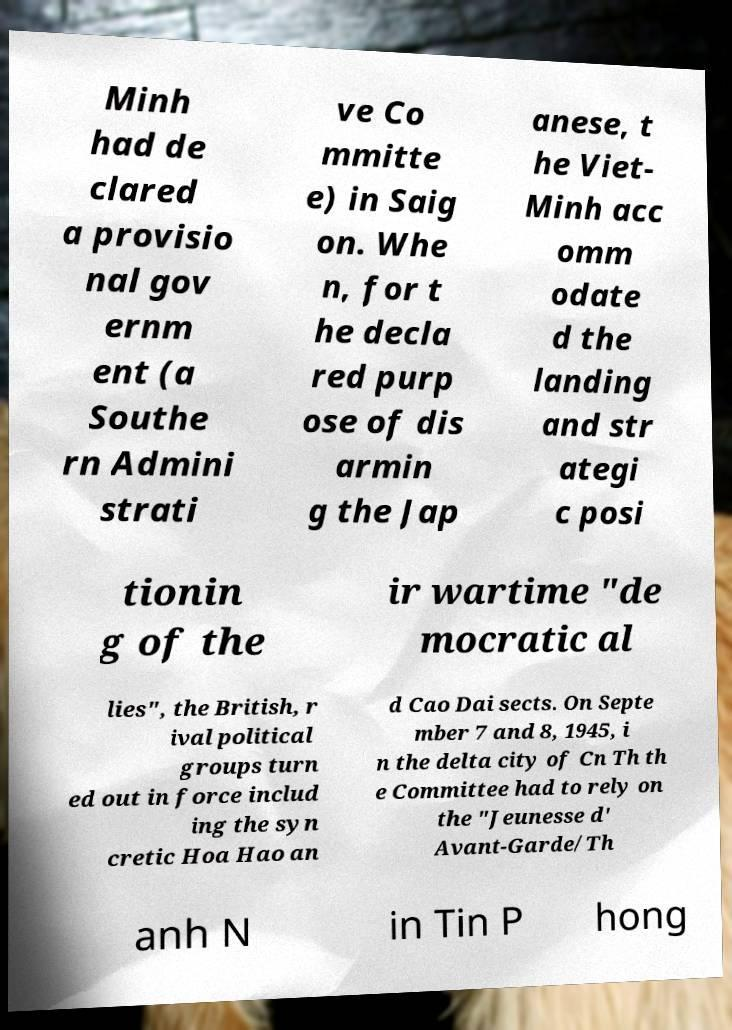Can you accurately transcribe the text from the provided image for me? Minh had de clared a provisio nal gov ernm ent (a Southe rn Admini strati ve Co mmitte e) in Saig on. Whe n, for t he decla red purp ose of dis armin g the Jap anese, t he Viet- Minh acc omm odate d the landing and str ategi c posi tionin g of the ir wartime "de mocratic al lies", the British, r ival political groups turn ed out in force includ ing the syn cretic Hoa Hao an d Cao Dai sects. On Septe mber 7 and 8, 1945, i n the delta city of Cn Th th e Committee had to rely on the "Jeunesse d' Avant-Garde/Th anh N in Tin P hong 